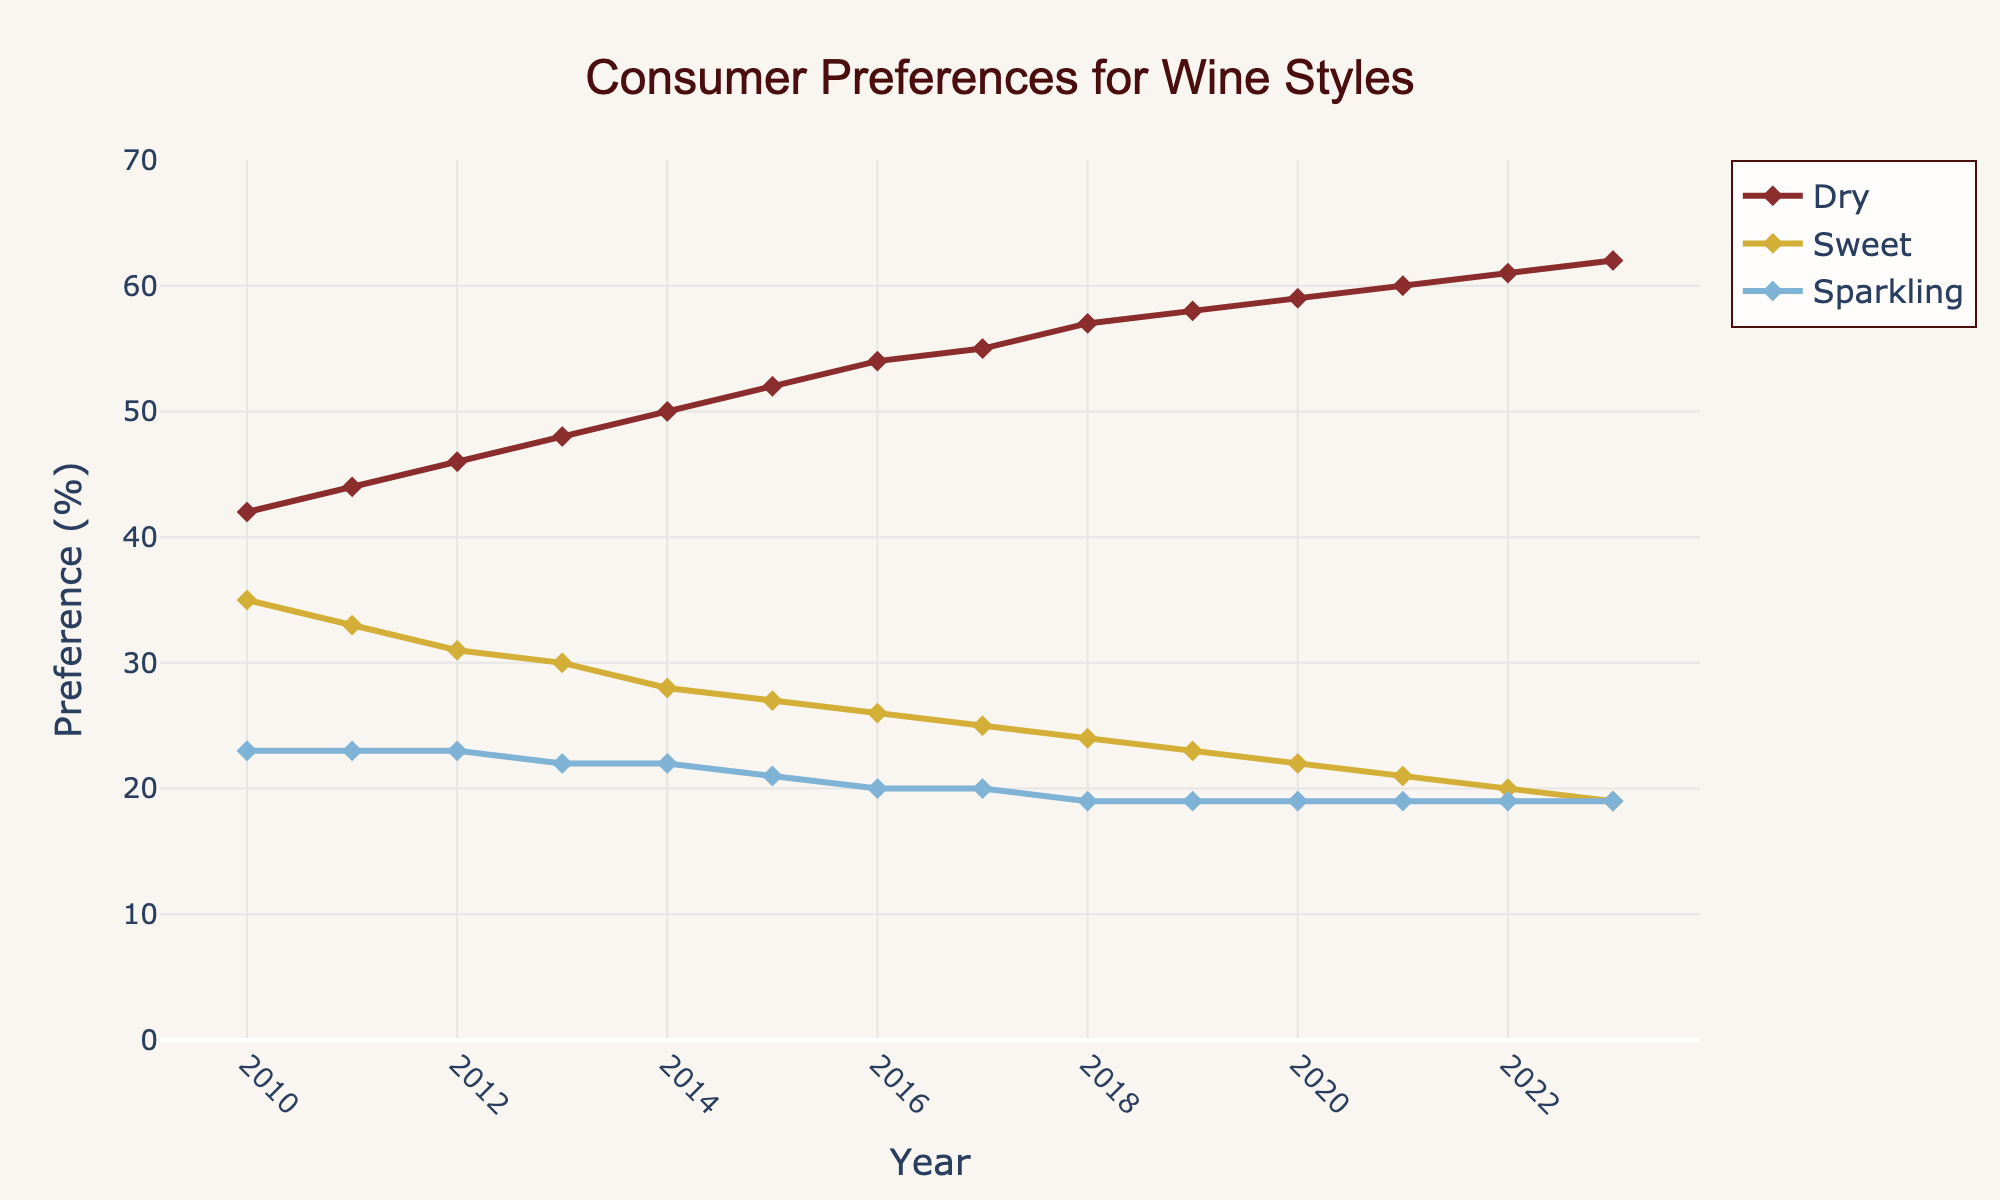Which wine style had the highest consumer preference in 2013? In 2013, the plot shows that the highest line is for "Dry" wine at 48%.
Answer: Dry How did the preference for sweet wine change from 2010 to 2023? The preference for sweet wine decreased from 35% in 2010 to 19% in 2023.
Answer: Decreased by 16% What was the average consumer preference for sparkling wine between 2010 and 2023? Adding the percentages for sparkling wine from each year (23 + 23 + 23 + 22 + 22 + 21 + 20 + 20 + 19 + 19 + 19 + 19 + 19 + 19) and dividing by the number of years (14) gives us the average. (273/14 = 19.5)
Answer: 19.5% Which year had the greatest increase in consumer preference for dry wine compared to the previous year? The change in preference for dry wine each year can be calculated. The greatest change occurred from 2018 to 2019, with an increase from 57% to 58%.
Answer: 2019 What is the combined consumer preference for dry and sparkling wines in 2020? In 2020, dry wine preference was 59% and sparkling wine preference was 19%. Adding these percentages gives 78%.
Answer: 78% How many years did the consumer preference for dry wine increase consecutively? The preference for dry wine increased every year from 2010 to 2023. This is a total of 13 consecutive years.
Answer: 13 years When did the consumer preference for sweet wine equal the preference for sparkling wine? The preference for sweet and sparkling wines was equal in 2023 at 19%.
Answer: 2023 By how much did the consumer preference for sparkling wine decrease from 2010 to 2023? The preference for sparkling wine in 2010 was 23% and in 2023 it was 19%. The decrease is calculated as 23% - 19% = 4%.
Answer: 4% Which wine style showed the most stability in consumer preference over the years? Sparkling wine consistently shows a stable line around 19%-23% with minimal deviation.
Answer: Sparkling What was the consumer preference trend for sweet wine from 2016 to 2023? From 2016 to 2023, the consumer preference for sweet wine shows a decreasing trend: 26% in 2016 down to 19% in 2023.
Answer: Decreasing 